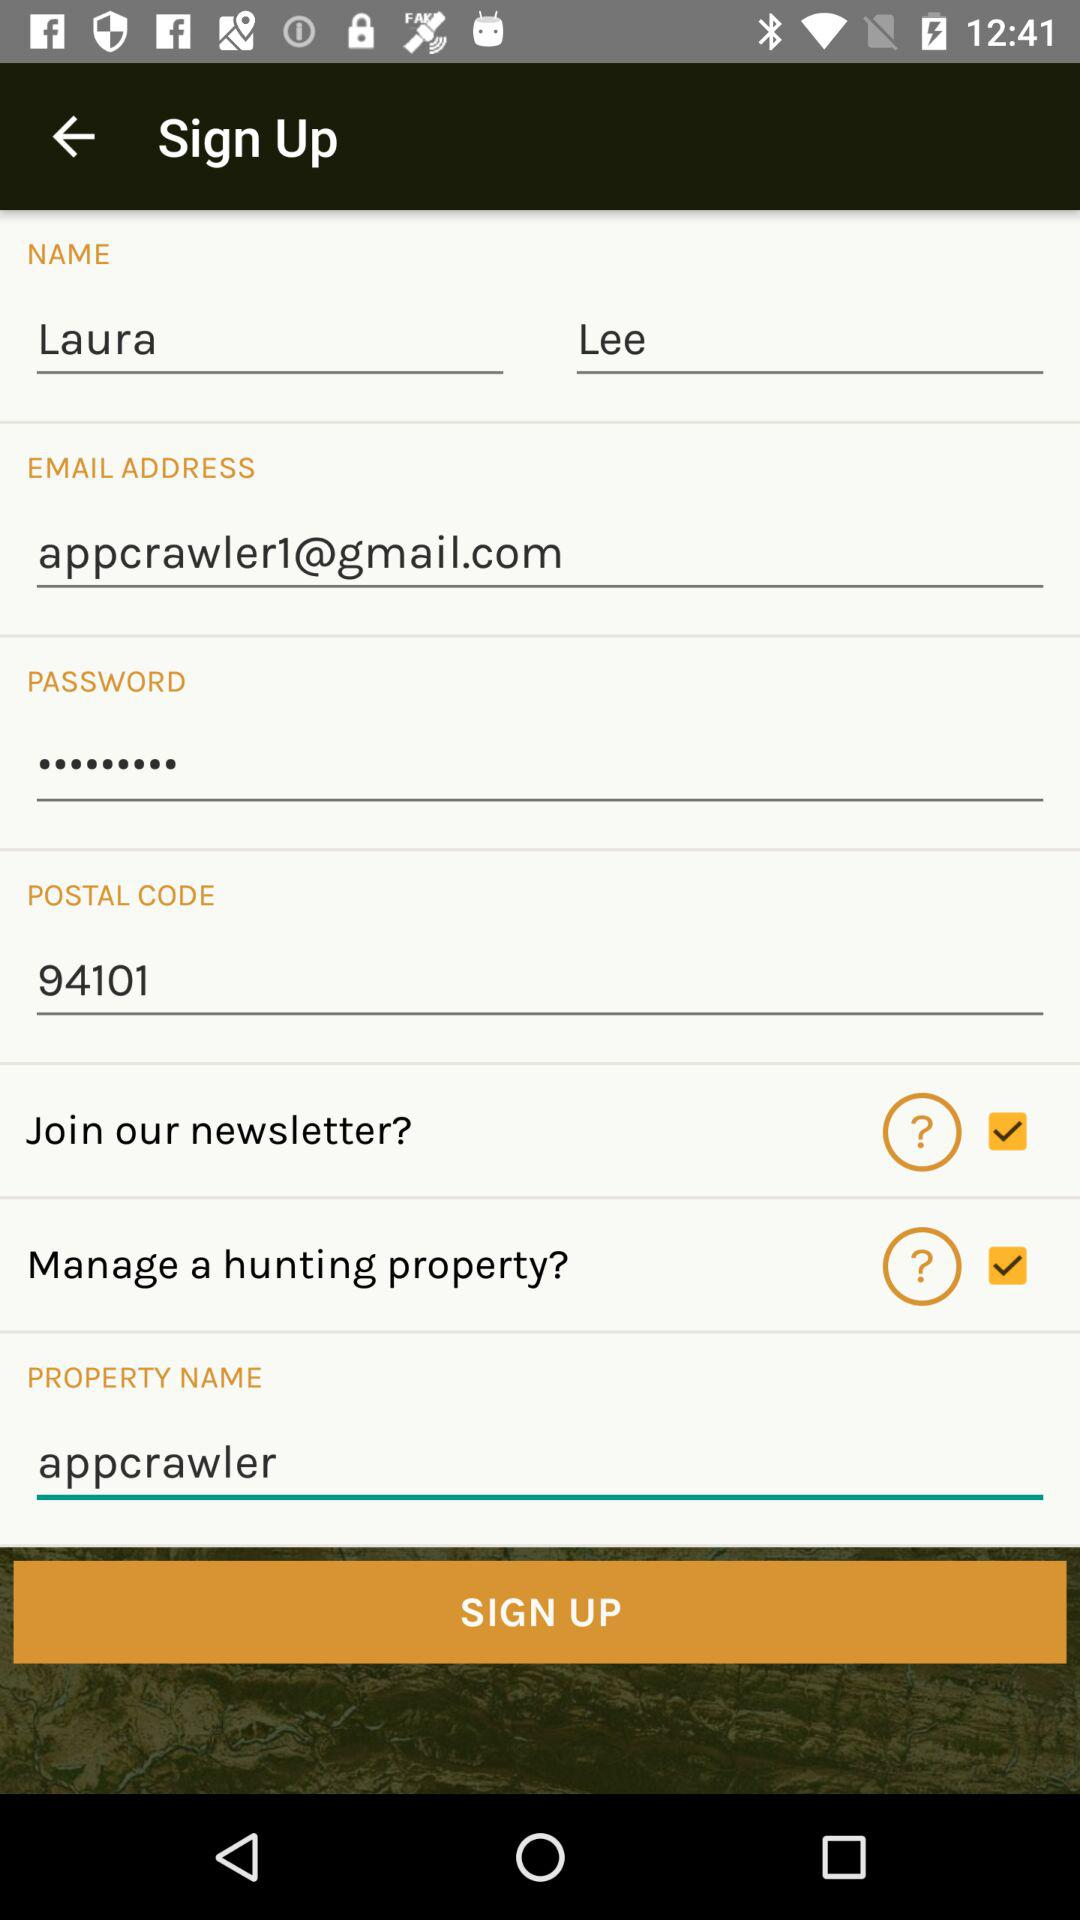How many check boxes are on the sign up form?
Answer the question using a single word or phrase. 2 